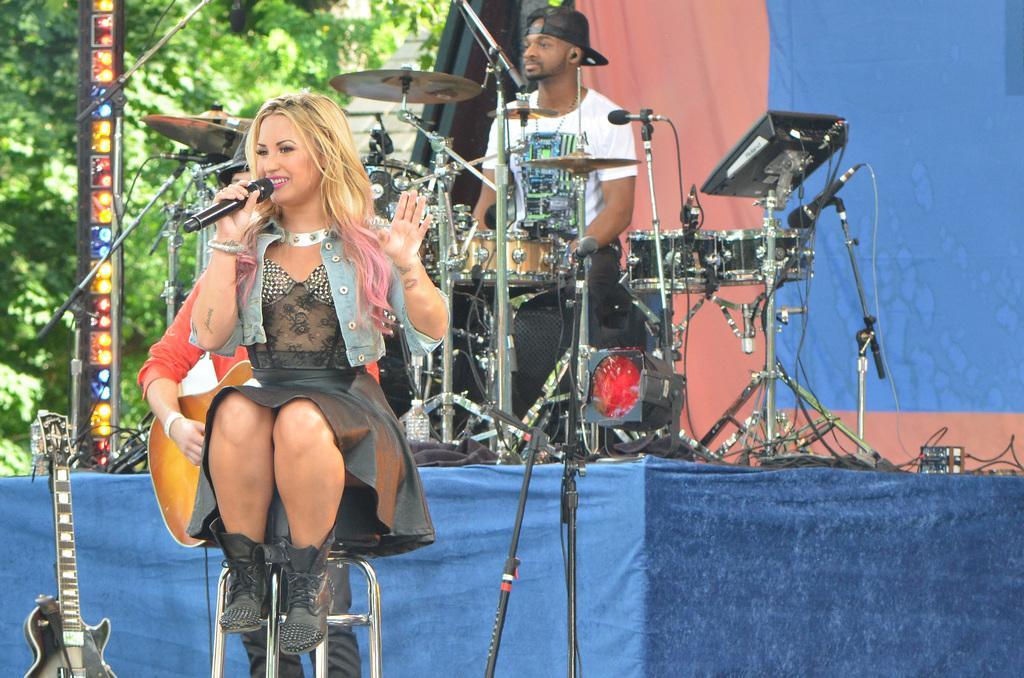How would you summarize this image in a sentence or two? There is a woman sitting on the stool holding a mic in her hand and in the background we can see a man sitting on stool playing the drums and here we can see the guitar and there are lights on the stage and different types of musical instruments like plates,drums and in the background we can see the tree and in the background we can see a curtain and in the backside of a woman someone is playing guitar and man sitting on stool is having a cap on his head. 